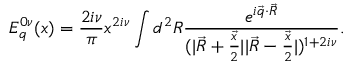Convert formula to latex. <formula><loc_0><loc_0><loc_500><loc_500>E _ { q } ^ { 0 \nu } ( x ) = { \frac { 2 i \nu } { \pi } } x ^ { 2 i \nu } \int d ^ { 2 } R { \frac { e ^ { i \vec { q } \cdot \vec { R } } } { ( | \vec { R } + { \frac { \vec { x } } { 2 } } | | \vec { R } - { \frac { \vec { x } } { 2 } } | ) ^ { 1 + 2 i \nu } } } .</formula> 